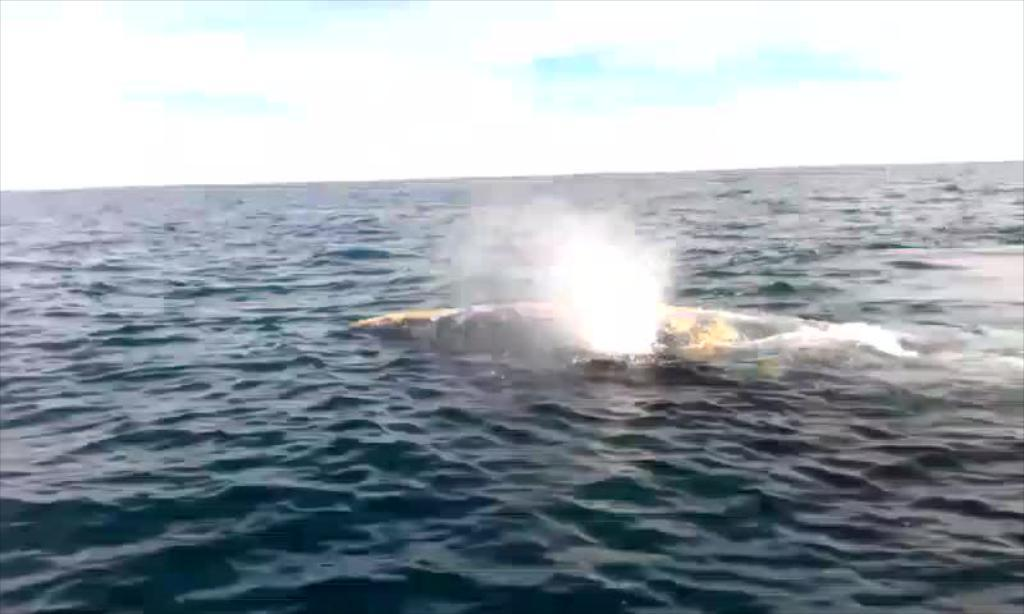Where was the picture taken? The picture was clicked outside the city. What can be seen in the center of the image? There is an object in the water body in the center of the image. What is visible in the background of the image? There is a sky visible in the background of the image. What type of cake is being served on the clock in the image? There is no cake or clock present in the image. 